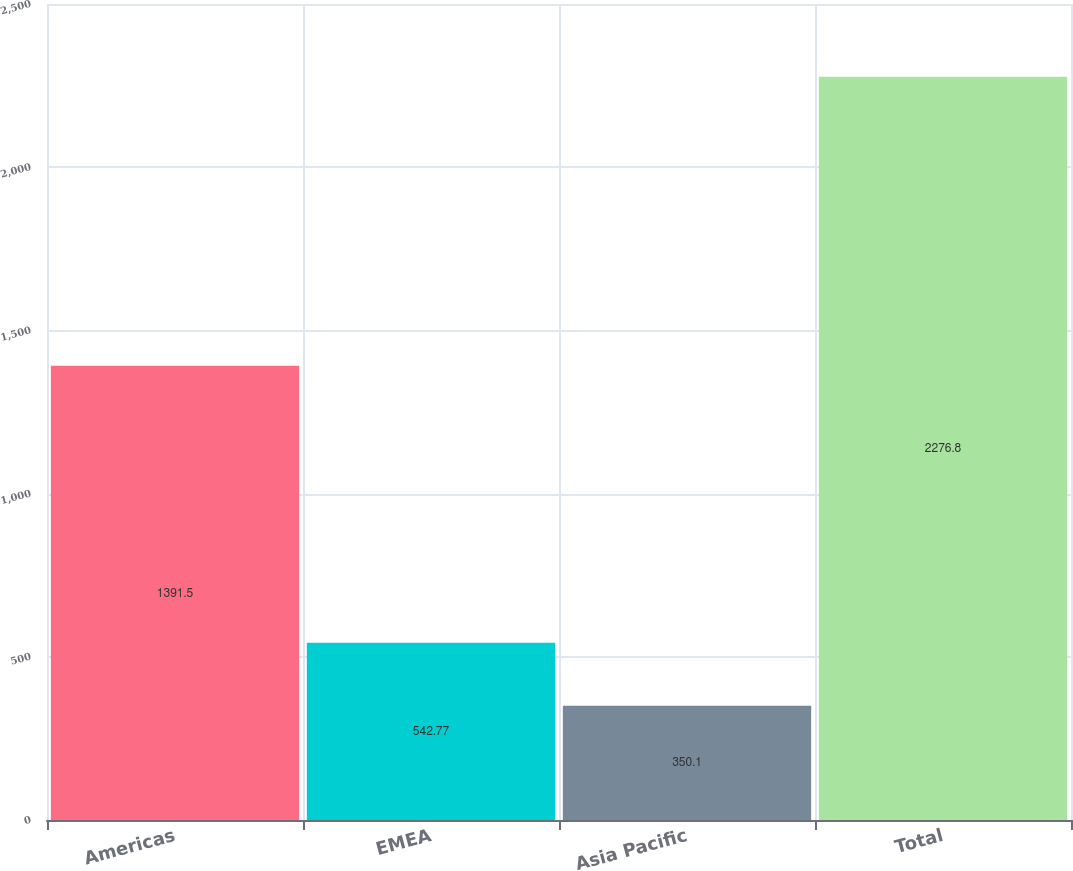Convert chart. <chart><loc_0><loc_0><loc_500><loc_500><bar_chart><fcel>Americas<fcel>EMEA<fcel>Asia Pacific<fcel>Total<nl><fcel>1391.5<fcel>542.77<fcel>350.1<fcel>2276.8<nl></chart> 